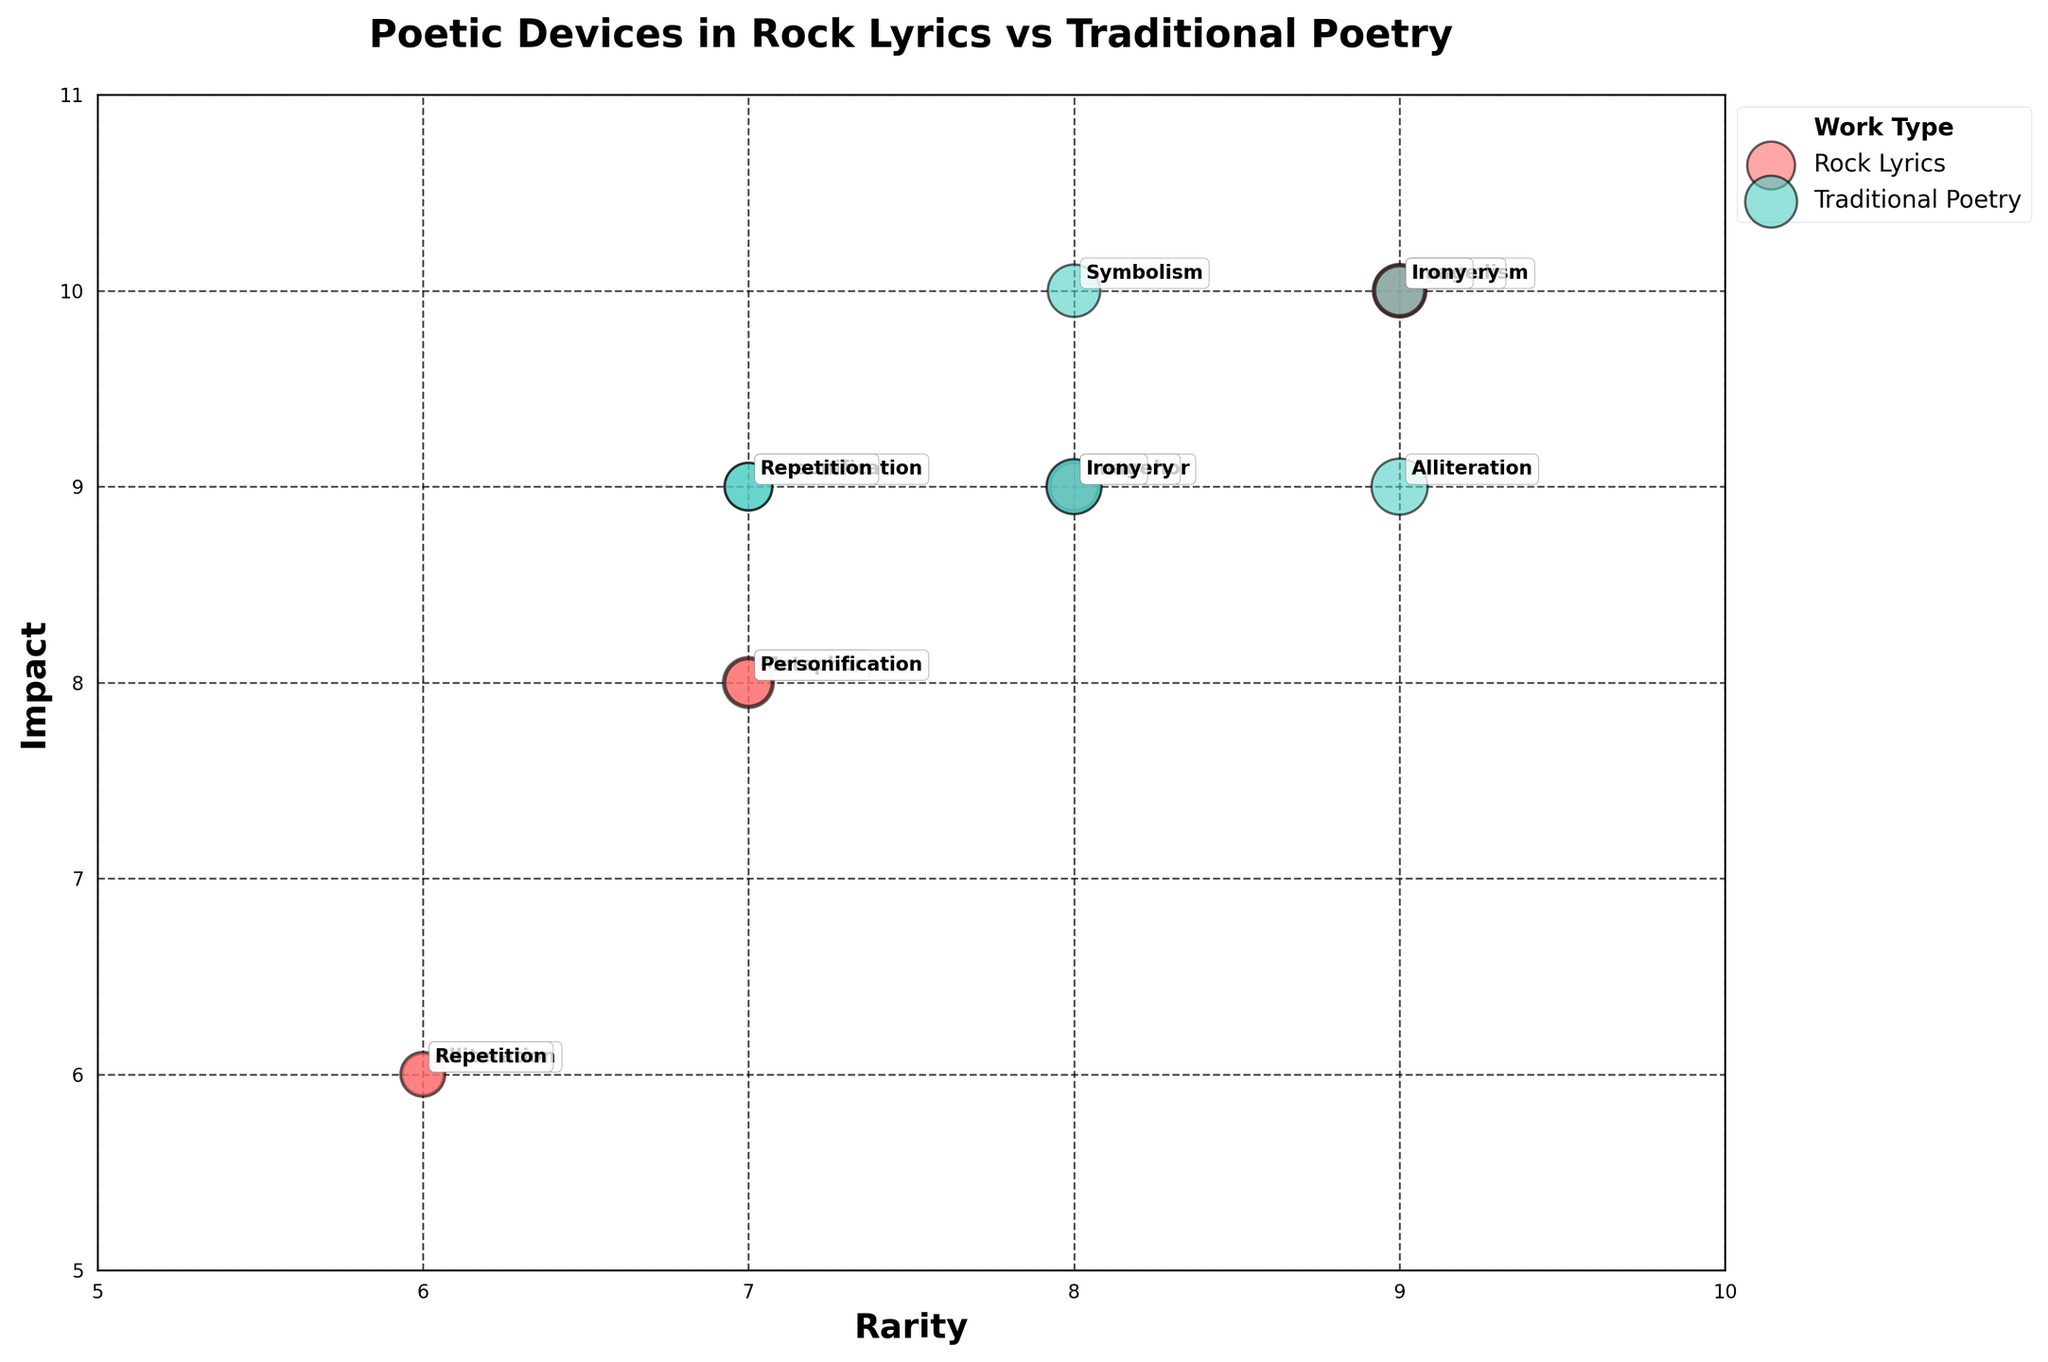How many types of poetic devices are represented in the figure? Count each unique poetic device labeled on the bubbles in the figure.
Answer: 7 What is the title of the figure? Read the title text at the top of the figure.
Answer: Poetic Devices in Rock Lyrics vs Traditional Poetry Which work type has the bubble with the highest frequency? Identify the largest bubble in the figure and note its work type.
Answer: Traditional Poetry Which poetic device has the highest impact score in rock lyrics? Look for the bubble labeled with a poetic device in the rock lyrics category and identify the one with the highest position on the "Impact" axis.
Answer: Symbolism Which poetic device has the lowest rarity score in traditional poetry? Look for the bubble labeled with a poetic device in the traditional poetry category and identify the one with the lowest position on the "Rarity" axis.
Answer: Repetition Compare the use of alliteration between rock lyrics and traditional poetry in terms of rarity and impact. Look at the bubbles labeled as alliteration in both work types and compare their positions along the rarity and impact axes. Traditional poetry has higher values for both rarity and impact than rock lyrics.
Answer: Traditional poetry has higher rarity and impact than rock lyrics What is the difference in frequency between the highest and lowest frequency poetic devices in rock lyrics? Identify the bubbles in the rock lyrics category with the highest and lowest frequencies, then subtract the lower frequency from the higher frequency.
Answer: 15 Which poetic device in traditional poetry has the closest frequency to 'Hotel California' in rock lyrics? Note the frequency of the poetic device in 'Hotel California' and compare it with the frequencies of traditional poetry poetic devices to find the closest match.
Answer: Repetition What are the average rarity values for rock lyrics and traditional poetry? Calculate the mean rarity value for each work type by adding the rarity scores for all bubbles in each category and dividing by the number of bubbles. For rock lyrics: (7+6+9+7+9+8 = 46/6 ≈ 7.67). For traditional poetry: (8+9+8+7+8+9+7 = 56/7 ≈ 8).
Answer: 7.67 (Rock Lyrics), 8 (Traditional Poetry) Which poetic device has the most similar impact score in both rock lyrics and traditional poetry? Identify the poetic devices where the impact scores of both work types are closest to each other by comparing their bubble positions along the impact axis.
Answer: Personification 